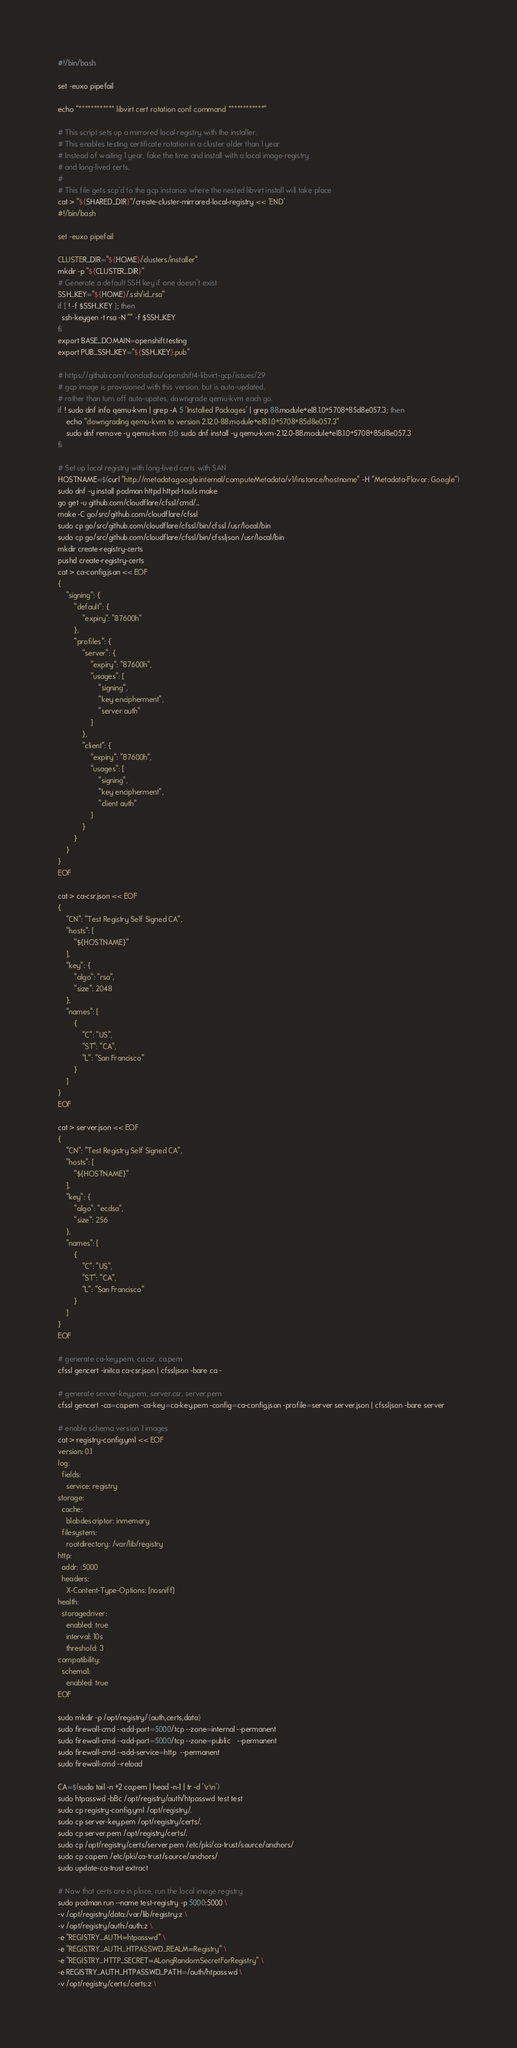Convert code to text. <code><loc_0><loc_0><loc_500><loc_500><_Bash_>#!/bin/bash

set -euxo pipefail

echo "************ libvirt cert rotation conf command ************"

# This script sets up a mirrored local registry with the installer.
# This enables testing certificate rotation in a cluster older than 1 year
# Instead of waiting 1 year, fake the time and install with a local image-registry
# and long-lived certs. 
#
# This file gets scp'd to the gcp instance where the nested libvirt install will take place
cat > "${SHARED_DIR}"/create-cluster-mirrored-local-registry << 'END'
#!/bin/bash

set -euxo pipefail

CLUSTER_DIR="${HOME}/clusters/installer"
mkdir -p "${CLUSTER_DIR}"
# Generate a default SSH key if one doesn't exist
SSH_KEY="${HOME}/.ssh/id_rsa"
if [ ! -f $SSH_KEY ]; then
  ssh-keygen -t rsa -N "" -f $SSH_KEY
fi
export BASE_DOMAIN=openshift.testing
export PUB_SSH_KEY="${SSH_KEY}.pub"

# https://github.com/ironcladlou/openshift4-libvirt-gcp/issues/29
# gcp image is provisioned with this version, but is auto-updated.
# rather than turn off auto-upates, downgrade qemu-kvm each go.
if ! sudo dnf info qemu-kvm | grep -A 5 'Installed Packages' | grep 88.module+el8.1.0+5708+85d8e057.3; then
    echo "downgrading qemu-kvm to version 2.12.0-88.module+el8.1.0+5708+85d8e057.3"
    sudo dnf remove -y qemu-kvm && sudo dnf install -y qemu-kvm-2.12.0-88.module+el8.1.0+5708+85d8e057.3
fi

# Set up local registry with long-lived certs with SAN
HOSTNAME=$(curl "http://metadata.google.internal/computeMetadata/v1/instance/hostname" -H "Metadata-Flavor: Google")
sudo dnf -y install podman httpd httpd-tools make
go get -u github.com/cloudflare/cfssl/cmd/...
make -C go/src/github.com/cloudflare/cfssl
sudo cp go/src/github.com/cloudflare/cfssl/bin/cfssl /usr/local/bin
sudo cp go/src/github.com/cloudflare/cfssl/bin/cfssljson /usr/local/bin
mkdir create-registry-certs
pushd create-registry-certs
cat > ca-config.json << EOF
{
    "signing": {
        "default": {
            "expiry": "87600h"
        },
        "profiles": {
            "server": {
                "expiry": "87600h",
                "usages": [
                    "signing",
                    "key encipherment",
                    "server auth"
                ]
            },
            "client": {
                "expiry": "87600h",
                "usages": [
                    "signing",
                    "key encipherment",
                    "client auth"
                ]
            }
        }
    }
}
EOF

cat > ca-csr.json << EOF
{
    "CN": "Test Registry Self Signed CA",
    "hosts": [
        "${HOSTNAME}"
    ],
    "key": {
        "algo": "rsa",
        "size": 2048
    },
    "names": [
        {
            "C": "US",
            "ST": "CA",
            "L": "San Francisco"
        }
    ]
}
EOF

cat > server.json << EOF
{
    "CN": "Test Registry Self Signed CA",
    "hosts": [
        "${HOSTNAME}"
    ],
    "key": {
        "algo": "ecdsa",
        "size": 256
    },
    "names": [
        {
            "C": "US",
            "ST": "CA",
            "L": "San Francisco"
        }
    ]
}
EOF

# generate ca-key.pem, ca.csr, ca.pem
cfssl gencert -initca ca-csr.json | cfssljson -bare ca -

# generate server-key.pem, server.csr, server.pem
cfssl gencert -ca=ca.pem -ca-key=ca-key.pem -config=ca-config.json -profile=server server.json | cfssljson -bare server

# enable schema version 1 images
cat > registry-config.yml << EOF
version: 0.1
log:
  fields:
    service: registry
storage:
  cache:
    blobdescriptor: inmemory
  filesystem:
    rootdirectory: /var/lib/registry
http:
  addr: :5000
  headers:
    X-Content-Type-Options: [nosniff]
health:
  storagedriver:
    enabled: true
    interval: 10s
    threshold: 3
compatibility:
  schema1:
    enabled: true
EOF

sudo mkdir -p /opt/registry/{auth,certs,data}
sudo firewall-cmd --add-port=5000/tcp --zone=internal --permanent
sudo firewall-cmd --add-port=5000/tcp --zone=public   --permanent
sudo firewall-cmd --add-service=http  --permanent
sudo firewall-cmd --reload

CA=$(sudo tail -n +2 ca.pem | head -n-1 | tr -d '\r\n')
sudo htpasswd -bBc /opt/registry/auth/htpasswd test test
sudo cp registry-config.yml /opt/registry/.
sudo cp server-key.pem /opt/registry/certs/.
sudo cp server.pem /opt/registry/certs/.
sudo cp /opt/registry/certs/server.pem /etc/pki/ca-trust/source/anchors/
sudo cp ca.pem /etc/pki/ca-trust/source/anchors/
sudo update-ca-trust extract

# Now that certs are in place, run the local image registry
sudo podman run --name test-registry -p 5000:5000 \
-v /opt/registry/data:/var/lib/registry:z \
-v /opt/registry/auth:/auth:z \
-e "REGISTRY_AUTH=htpasswd" \
-e "REGISTRY_AUTH_HTPASSWD_REALM=Registry" \
-e "REGISTRY_HTTP_SECRET=ALongRandomSecretForRegistry" \
-e REGISTRY_AUTH_HTPASSWD_PATH=/auth/htpasswd \
-v /opt/registry/certs:/certs:z \</code> 